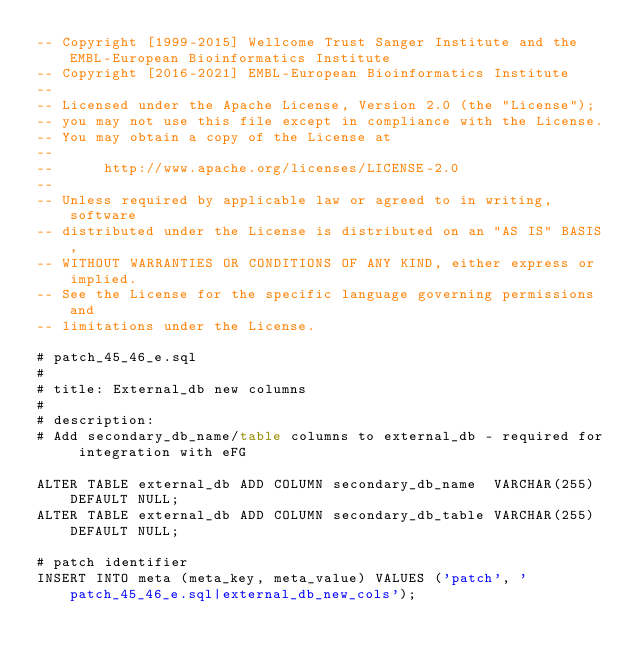<code> <loc_0><loc_0><loc_500><loc_500><_SQL_>-- Copyright [1999-2015] Wellcome Trust Sanger Institute and the EMBL-European Bioinformatics Institute
-- Copyright [2016-2021] EMBL-European Bioinformatics Institute
-- 
-- Licensed under the Apache License, Version 2.0 (the "License");
-- you may not use this file except in compliance with the License.
-- You may obtain a copy of the License at
-- 
--      http://www.apache.org/licenses/LICENSE-2.0
-- 
-- Unless required by applicable law or agreed to in writing, software
-- distributed under the License is distributed on an "AS IS" BASIS,
-- WITHOUT WARRANTIES OR CONDITIONS OF ANY KIND, either express or implied.
-- See the License for the specific language governing permissions and
-- limitations under the License.

# patch_45_46_e.sql
#
# title: External_db new columns
#
# description:
# Add secondary_db_name/table columns to external_db - required for integration with eFG

ALTER TABLE external_db ADD COLUMN secondary_db_name  VARCHAR(255) DEFAULT NULL;
ALTER TABLE external_db ADD COLUMN secondary_db_table VARCHAR(255) DEFAULT NULL;

# patch identifier
INSERT INTO meta (meta_key, meta_value) VALUES ('patch', 'patch_45_46_e.sql|external_db_new_cols');
</code> 